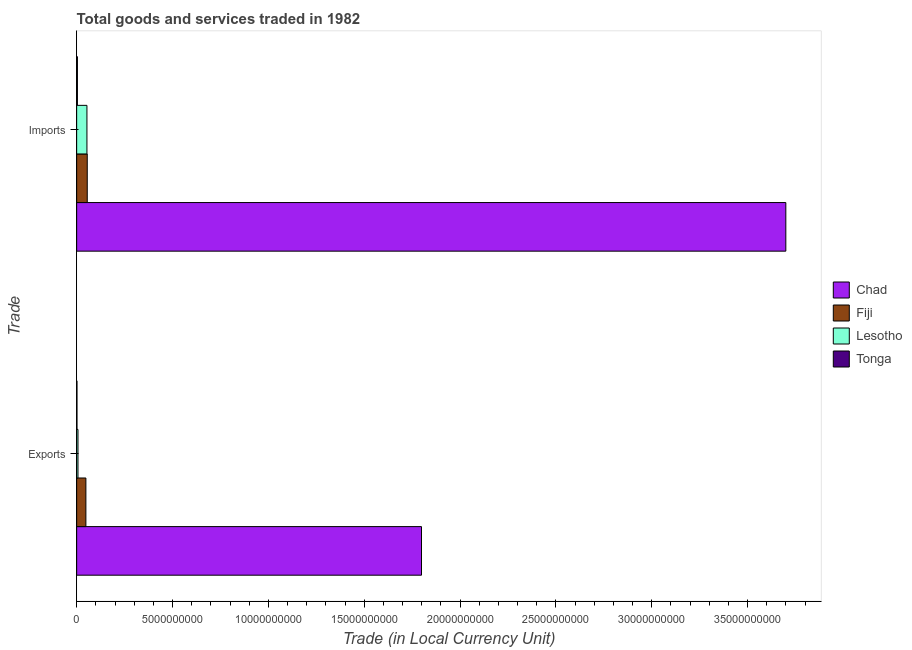How many groups of bars are there?
Keep it short and to the point. 2. Are the number of bars on each tick of the Y-axis equal?
Keep it short and to the point. Yes. What is the label of the 2nd group of bars from the top?
Provide a succinct answer. Exports. What is the export of goods and services in Lesotho?
Give a very brief answer. 6.90e+07. Across all countries, what is the maximum export of goods and services?
Provide a succinct answer. 1.80e+1. Across all countries, what is the minimum export of goods and services?
Ensure brevity in your answer.  1.69e+07. In which country was the export of goods and services maximum?
Give a very brief answer. Chad. In which country was the export of goods and services minimum?
Make the answer very short. Tonga. What is the total imports of goods and services in the graph?
Ensure brevity in your answer.  3.81e+1. What is the difference between the export of goods and services in Lesotho and that in Fiji?
Keep it short and to the point. -4.12e+08. What is the difference between the imports of goods and services in Lesotho and the export of goods and services in Chad?
Your answer should be very brief. -1.75e+1. What is the average imports of goods and services per country?
Your response must be concise. 9.53e+09. What is the difference between the export of goods and services and imports of goods and services in Fiji?
Ensure brevity in your answer.  -7.13e+07. What is the ratio of the imports of goods and services in Chad to that in Tonga?
Provide a short and direct response. 935.62. In how many countries, is the imports of goods and services greater than the average imports of goods and services taken over all countries?
Keep it short and to the point. 1. What does the 3rd bar from the top in Exports represents?
Keep it short and to the point. Fiji. What does the 4th bar from the bottom in Imports represents?
Give a very brief answer. Tonga. Are all the bars in the graph horizontal?
Provide a succinct answer. Yes. Are the values on the major ticks of X-axis written in scientific E-notation?
Offer a very short reply. No. Does the graph contain any zero values?
Your answer should be compact. No. Does the graph contain grids?
Your response must be concise. No. Where does the legend appear in the graph?
Offer a terse response. Center right. How many legend labels are there?
Your answer should be very brief. 4. What is the title of the graph?
Offer a very short reply. Total goods and services traded in 1982. Does "Kuwait" appear as one of the legend labels in the graph?
Make the answer very short. No. What is the label or title of the X-axis?
Keep it short and to the point. Trade (in Local Currency Unit). What is the label or title of the Y-axis?
Give a very brief answer. Trade. What is the Trade (in Local Currency Unit) in Chad in Exports?
Your answer should be compact. 1.80e+1. What is the Trade (in Local Currency Unit) of Fiji in Exports?
Keep it short and to the point. 4.81e+08. What is the Trade (in Local Currency Unit) in Lesotho in Exports?
Ensure brevity in your answer.  6.90e+07. What is the Trade (in Local Currency Unit) of Tonga in Exports?
Provide a short and direct response. 1.69e+07. What is the Trade (in Local Currency Unit) in Chad in Imports?
Give a very brief answer. 3.70e+1. What is the Trade (in Local Currency Unit) of Fiji in Imports?
Your answer should be very brief. 5.53e+08. What is the Trade (in Local Currency Unit) of Lesotho in Imports?
Your answer should be compact. 5.36e+08. What is the Trade (in Local Currency Unit) in Tonga in Imports?
Keep it short and to the point. 3.95e+07. Across all Trade, what is the maximum Trade (in Local Currency Unit) in Chad?
Provide a succinct answer. 3.70e+1. Across all Trade, what is the maximum Trade (in Local Currency Unit) of Fiji?
Give a very brief answer. 5.53e+08. Across all Trade, what is the maximum Trade (in Local Currency Unit) of Lesotho?
Make the answer very short. 5.36e+08. Across all Trade, what is the maximum Trade (in Local Currency Unit) of Tonga?
Your response must be concise. 3.95e+07. Across all Trade, what is the minimum Trade (in Local Currency Unit) of Chad?
Provide a short and direct response. 1.80e+1. Across all Trade, what is the minimum Trade (in Local Currency Unit) of Fiji?
Provide a short and direct response. 4.81e+08. Across all Trade, what is the minimum Trade (in Local Currency Unit) of Lesotho?
Your answer should be very brief. 6.90e+07. Across all Trade, what is the minimum Trade (in Local Currency Unit) in Tonga?
Make the answer very short. 1.69e+07. What is the total Trade (in Local Currency Unit) of Chad in the graph?
Give a very brief answer. 5.50e+1. What is the total Trade (in Local Currency Unit) of Fiji in the graph?
Ensure brevity in your answer.  1.03e+09. What is the total Trade (in Local Currency Unit) of Lesotho in the graph?
Your response must be concise. 6.05e+08. What is the total Trade (in Local Currency Unit) in Tonga in the graph?
Your response must be concise. 5.64e+07. What is the difference between the Trade (in Local Currency Unit) of Chad in Exports and that in Imports?
Provide a succinct answer. -1.90e+1. What is the difference between the Trade (in Local Currency Unit) of Fiji in Exports and that in Imports?
Provide a short and direct response. -7.13e+07. What is the difference between the Trade (in Local Currency Unit) of Lesotho in Exports and that in Imports?
Give a very brief answer. -4.67e+08. What is the difference between the Trade (in Local Currency Unit) in Tonga in Exports and that in Imports?
Offer a terse response. -2.27e+07. What is the difference between the Trade (in Local Currency Unit) in Chad in Exports and the Trade (in Local Currency Unit) in Fiji in Imports?
Provide a short and direct response. 1.74e+1. What is the difference between the Trade (in Local Currency Unit) in Chad in Exports and the Trade (in Local Currency Unit) in Lesotho in Imports?
Your answer should be compact. 1.75e+1. What is the difference between the Trade (in Local Currency Unit) in Chad in Exports and the Trade (in Local Currency Unit) in Tonga in Imports?
Your answer should be very brief. 1.80e+1. What is the difference between the Trade (in Local Currency Unit) of Fiji in Exports and the Trade (in Local Currency Unit) of Lesotho in Imports?
Give a very brief answer. -5.47e+07. What is the difference between the Trade (in Local Currency Unit) in Fiji in Exports and the Trade (in Local Currency Unit) in Tonga in Imports?
Offer a very short reply. 4.42e+08. What is the difference between the Trade (in Local Currency Unit) in Lesotho in Exports and the Trade (in Local Currency Unit) in Tonga in Imports?
Give a very brief answer. 2.95e+07. What is the average Trade (in Local Currency Unit) of Chad per Trade?
Provide a succinct answer. 2.75e+1. What is the average Trade (in Local Currency Unit) of Fiji per Trade?
Ensure brevity in your answer.  5.17e+08. What is the average Trade (in Local Currency Unit) in Lesotho per Trade?
Provide a short and direct response. 3.03e+08. What is the average Trade (in Local Currency Unit) of Tonga per Trade?
Offer a terse response. 2.82e+07. What is the difference between the Trade (in Local Currency Unit) of Chad and Trade (in Local Currency Unit) of Fiji in Exports?
Keep it short and to the point. 1.75e+1. What is the difference between the Trade (in Local Currency Unit) in Chad and Trade (in Local Currency Unit) in Lesotho in Exports?
Your answer should be compact. 1.79e+1. What is the difference between the Trade (in Local Currency Unit) of Chad and Trade (in Local Currency Unit) of Tonga in Exports?
Provide a short and direct response. 1.80e+1. What is the difference between the Trade (in Local Currency Unit) in Fiji and Trade (in Local Currency Unit) in Lesotho in Exports?
Offer a very short reply. 4.12e+08. What is the difference between the Trade (in Local Currency Unit) in Fiji and Trade (in Local Currency Unit) in Tonga in Exports?
Make the answer very short. 4.64e+08. What is the difference between the Trade (in Local Currency Unit) of Lesotho and Trade (in Local Currency Unit) of Tonga in Exports?
Your response must be concise. 5.21e+07. What is the difference between the Trade (in Local Currency Unit) in Chad and Trade (in Local Currency Unit) in Fiji in Imports?
Offer a very short reply. 3.64e+1. What is the difference between the Trade (in Local Currency Unit) of Chad and Trade (in Local Currency Unit) of Lesotho in Imports?
Provide a short and direct response. 3.65e+1. What is the difference between the Trade (in Local Currency Unit) in Chad and Trade (in Local Currency Unit) in Tonga in Imports?
Offer a terse response. 3.70e+1. What is the difference between the Trade (in Local Currency Unit) in Fiji and Trade (in Local Currency Unit) in Lesotho in Imports?
Give a very brief answer. 1.66e+07. What is the difference between the Trade (in Local Currency Unit) of Fiji and Trade (in Local Currency Unit) of Tonga in Imports?
Offer a terse response. 5.13e+08. What is the difference between the Trade (in Local Currency Unit) in Lesotho and Trade (in Local Currency Unit) in Tonga in Imports?
Make the answer very short. 4.96e+08. What is the ratio of the Trade (in Local Currency Unit) in Chad in Exports to that in Imports?
Offer a terse response. 0.49. What is the ratio of the Trade (in Local Currency Unit) of Fiji in Exports to that in Imports?
Your answer should be very brief. 0.87. What is the ratio of the Trade (in Local Currency Unit) in Lesotho in Exports to that in Imports?
Provide a short and direct response. 0.13. What is the ratio of the Trade (in Local Currency Unit) of Tonga in Exports to that in Imports?
Provide a short and direct response. 0.43. What is the difference between the highest and the second highest Trade (in Local Currency Unit) in Chad?
Provide a short and direct response. 1.90e+1. What is the difference between the highest and the second highest Trade (in Local Currency Unit) of Fiji?
Offer a terse response. 7.13e+07. What is the difference between the highest and the second highest Trade (in Local Currency Unit) in Lesotho?
Offer a very short reply. 4.67e+08. What is the difference between the highest and the second highest Trade (in Local Currency Unit) of Tonga?
Your response must be concise. 2.27e+07. What is the difference between the highest and the lowest Trade (in Local Currency Unit) in Chad?
Give a very brief answer. 1.90e+1. What is the difference between the highest and the lowest Trade (in Local Currency Unit) in Fiji?
Your response must be concise. 7.13e+07. What is the difference between the highest and the lowest Trade (in Local Currency Unit) in Lesotho?
Give a very brief answer. 4.67e+08. What is the difference between the highest and the lowest Trade (in Local Currency Unit) of Tonga?
Offer a very short reply. 2.27e+07. 